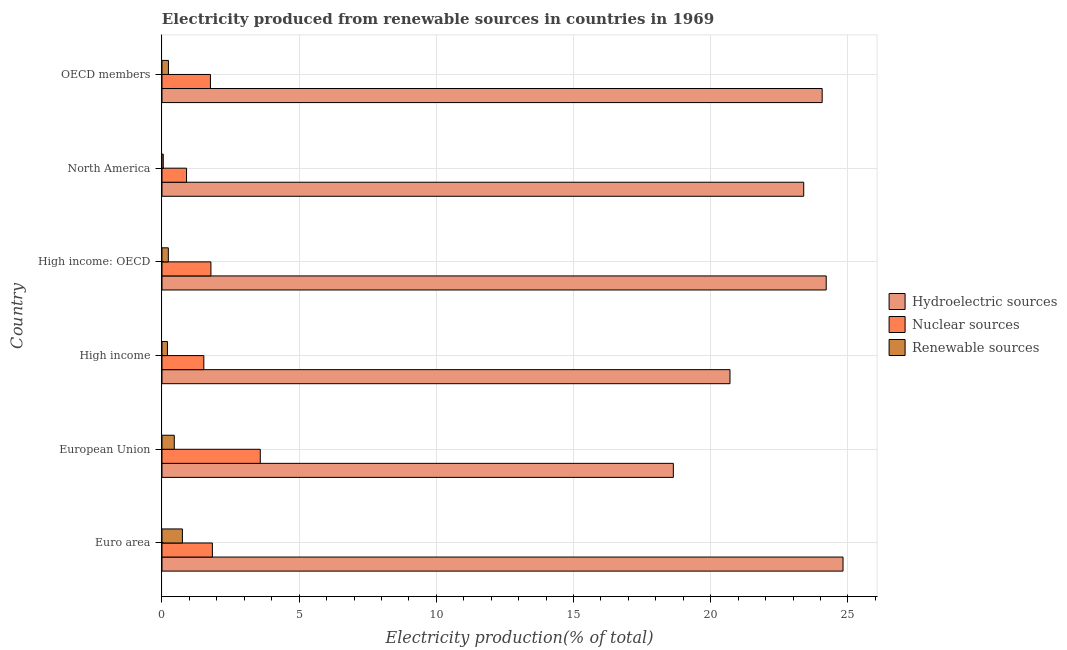How many different coloured bars are there?
Your answer should be very brief. 3. How many groups of bars are there?
Ensure brevity in your answer.  6. What is the label of the 6th group of bars from the top?
Provide a succinct answer. Euro area. What is the percentage of electricity produced by hydroelectric sources in High income: OECD?
Provide a succinct answer. 24.21. Across all countries, what is the maximum percentage of electricity produced by nuclear sources?
Your answer should be compact. 3.58. Across all countries, what is the minimum percentage of electricity produced by nuclear sources?
Make the answer very short. 0.9. What is the total percentage of electricity produced by nuclear sources in the graph?
Provide a succinct answer. 11.39. What is the difference between the percentage of electricity produced by nuclear sources in European Union and that in OECD members?
Provide a short and direct response. 1.82. What is the difference between the percentage of electricity produced by nuclear sources in North America and the percentage of electricity produced by hydroelectric sources in European Union?
Provide a short and direct response. -17.74. What is the average percentage of electricity produced by hydroelectric sources per country?
Give a very brief answer. 22.64. What is the difference between the percentage of electricity produced by hydroelectric sources and percentage of electricity produced by nuclear sources in European Union?
Keep it short and to the point. 15.05. In how many countries, is the percentage of electricity produced by hydroelectric sources greater than 10 %?
Make the answer very short. 6. What is the ratio of the percentage of electricity produced by nuclear sources in Euro area to that in High income: OECD?
Your response must be concise. 1.03. Is the difference between the percentage of electricity produced by nuclear sources in Euro area and High income: OECD greater than the difference between the percentage of electricity produced by hydroelectric sources in Euro area and High income: OECD?
Make the answer very short. No. What is the difference between the highest and the second highest percentage of electricity produced by hydroelectric sources?
Your response must be concise. 0.61. What is the difference between the highest and the lowest percentage of electricity produced by nuclear sources?
Offer a very short reply. 2.69. In how many countries, is the percentage of electricity produced by nuclear sources greater than the average percentage of electricity produced by nuclear sources taken over all countries?
Give a very brief answer. 1. What does the 3rd bar from the top in OECD members represents?
Ensure brevity in your answer.  Hydroelectric sources. What does the 2nd bar from the bottom in Euro area represents?
Give a very brief answer. Nuclear sources. Is it the case that in every country, the sum of the percentage of electricity produced by hydroelectric sources and percentage of electricity produced by nuclear sources is greater than the percentage of electricity produced by renewable sources?
Your response must be concise. Yes. How many bars are there?
Offer a very short reply. 18. Are the values on the major ticks of X-axis written in scientific E-notation?
Give a very brief answer. No. Does the graph contain any zero values?
Your response must be concise. No. Does the graph contain grids?
Offer a terse response. Yes. Where does the legend appear in the graph?
Offer a terse response. Center right. How many legend labels are there?
Keep it short and to the point. 3. What is the title of the graph?
Provide a succinct answer. Electricity produced from renewable sources in countries in 1969. What is the Electricity production(% of total) in Hydroelectric sources in Euro area?
Your response must be concise. 24.82. What is the Electricity production(% of total) in Nuclear sources in Euro area?
Provide a short and direct response. 1.84. What is the Electricity production(% of total) in Renewable sources in Euro area?
Keep it short and to the point. 0.74. What is the Electricity production(% of total) of Hydroelectric sources in European Union?
Make the answer very short. 18.64. What is the Electricity production(% of total) in Nuclear sources in European Union?
Provide a short and direct response. 3.58. What is the Electricity production(% of total) of Renewable sources in European Union?
Your answer should be very brief. 0.45. What is the Electricity production(% of total) in Hydroelectric sources in High income?
Keep it short and to the point. 20.7. What is the Electricity production(% of total) of Nuclear sources in High income?
Your answer should be compact. 1.53. What is the Electricity production(% of total) in Renewable sources in High income?
Give a very brief answer. 0.2. What is the Electricity production(% of total) in Hydroelectric sources in High income: OECD?
Provide a short and direct response. 24.21. What is the Electricity production(% of total) of Nuclear sources in High income: OECD?
Ensure brevity in your answer.  1.78. What is the Electricity production(% of total) in Renewable sources in High income: OECD?
Provide a short and direct response. 0.23. What is the Electricity production(% of total) of Hydroelectric sources in North America?
Keep it short and to the point. 23.39. What is the Electricity production(% of total) of Nuclear sources in North America?
Your response must be concise. 0.9. What is the Electricity production(% of total) in Renewable sources in North America?
Offer a very short reply. 0.05. What is the Electricity production(% of total) of Hydroelectric sources in OECD members?
Provide a succinct answer. 24.06. What is the Electricity production(% of total) of Nuclear sources in OECD members?
Your answer should be very brief. 1.77. What is the Electricity production(% of total) in Renewable sources in OECD members?
Make the answer very short. 0.23. Across all countries, what is the maximum Electricity production(% of total) in Hydroelectric sources?
Your answer should be very brief. 24.82. Across all countries, what is the maximum Electricity production(% of total) of Nuclear sources?
Your answer should be very brief. 3.58. Across all countries, what is the maximum Electricity production(% of total) of Renewable sources?
Provide a succinct answer. 0.74. Across all countries, what is the minimum Electricity production(% of total) of Hydroelectric sources?
Give a very brief answer. 18.64. Across all countries, what is the minimum Electricity production(% of total) of Nuclear sources?
Your answer should be compact. 0.9. Across all countries, what is the minimum Electricity production(% of total) in Renewable sources?
Ensure brevity in your answer.  0.05. What is the total Electricity production(% of total) in Hydroelectric sources in the graph?
Offer a very short reply. 135.82. What is the total Electricity production(% of total) in Nuclear sources in the graph?
Provide a succinct answer. 11.39. What is the total Electricity production(% of total) in Renewable sources in the graph?
Provide a succinct answer. 1.9. What is the difference between the Electricity production(% of total) of Hydroelectric sources in Euro area and that in European Union?
Keep it short and to the point. 6.18. What is the difference between the Electricity production(% of total) of Nuclear sources in Euro area and that in European Union?
Provide a succinct answer. -1.75. What is the difference between the Electricity production(% of total) in Renewable sources in Euro area and that in European Union?
Ensure brevity in your answer.  0.3. What is the difference between the Electricity production(% of total) of Hydroelectric sources in Euro area and that in High income?
Ensure brevity in your answer.  4.12. What is the difference between the Electricity production(% of total) in Nuclear sources in Euro area and that in High income?
Offer a terse response. 0.31. What is the difference between the Electricity production(% of total) of Renewable sources in Euro area and that in High income?
Ensure brevity in your answer.  0.55. What is the difference between the Electricity production(% of total) of Hydroelectric sources in Euro area and that in High income: OECD?
Your answer should be compact. 0.61. What is the difference between the Electricity production(% of total) of Nuclear sources in Euro area and that in High income: OECD?
Give a very brief answer. 0.05. What is the difference between the Electricity production(% of total) of Renewable sources in Euro area and that in High income: OECD?
Your answer should be very brief. 0.51. What is the difference between the Electricity production(% of total) in Hydroelectric sources in Euro area and that in North America?
Offer a very short reply. 1.43. What is the difference between the Electricity production(% of total) in Nuclear sources in Euro area and that in North America?
Your answer should be compact. 0.94. What is the difference between the Electricity production(% of total) in Renewable sources in Euro area and that in North America?
Give a very brief answer. 0.7. What is the difference between the Electricity production(% of total) in Hydroelectric sources in Euro area and that in OECD members?
Offer a terse response. 0.76. What is the difference between the Electricity production(% of total) in Nuclear sources in Euro area and that in OECD members?
Provide a short and direct response. 0.07. What is the difference between the Electricity production(% of total) of Renewable sources in Euro area and that in OECD members?
Your answer should be very brief. 0.51. What is the difference between the Electricity production(% of total) of Hydroelectric sources in European Union and that in High income?
Offer a very short reply. -2.07. What is the difference between the Electricity production(% of total) in Nuclear sources in European Union and that in High income?
Provide a succinct answer. 2.06. What is the difference between the Electricity production(% of total) of Renewable sources in European Union and that in High income?
Provide a succinct answer. 0.25. What is the difference between the Electricity production(% of total) of Hydroelectric sources in European Union and that in High income: OECD?
Make the answer very short. -5.57. What is the difference between the Electricity production(% of total) of Nuclear sources in European Union and that in High income: OECD?
Give a very brief answer. 1.8. What is the difference between the Electricity production(% of total) of Renewable sources in European Union and that in High income: OECD?
Your answer should be compact. 0.22. What is the difference between the Electricity production(% of total) of Hydroelectric sources in European Union and that in North America?
Your response must be concise. -4.75. What is the difference between the Electricity production(% of total) of Nuclear sources in European Union and that in North America?
Ensure brevity in your answer.  2.69. What is the difference between the Electricity production(% of total) in Renewable sources in European Union and that in North America?
Ensure brevity in your answer.  0.4. What is the difference between the Electricity production(% of total) of Hydroelectric sources in European Union and that in OECD members?
Make the answer very short. -5.42. What is the difference between the Electricity production(% of total) in Nuclear sources in European Union and that in OECD members?
Your answer should be compact. 1.82. What is the difference between the Electricity production(% of total) in Renewable sources in European Union and that in OECD members?
Ensure brevity in your answer.  0.21. What is the difference between the Electricity production(% of total) of Hydroelectric sources in High income and that in High income: OECD?
Give a very brief answer. -3.51. What is the difference between the Electricity production(% of total) in Nuclear sources in High income and that in High income: OECD?
Your response must be concise. -0.26. What is the difference between the Electricity production(% of total) of Renewable sources in High income and that in High income: OECD?
Provide a short and direct response. -0.03. What is the difference between the Electricity production(% of total) in Hydroelectric sources in High income and that in North America?
Keep it short and to the point. -2.69. What is the difference between the Electricity production(% of total) in Nuclear sources in High income and that in North America?
Offer a terse response. 0.63. What is the difference between the Electricity production(% of total) in Renewable sources in High income and that in North America?
Offer a terse response. 0.15. What is the difference between the Electricity production(% of total) in Hydroelectric sources in High income and that in OECD members?
Provide a short and direct response. -3.36. What is the difference between the Electricity production(% of total) of Nuclear sources in High income and that in OECD members?
Give a very brief answer. -0.24. What is the difference between the Electricity production(% of total) in Renewable sources in High income and that in OECD members?
Provide a short and direct response. -0.04. What is the difference between the Electricity production(% of total) in Hydroelectric sources in High income: OECD and that in North America?
Offer a terse response. 0.82. What is the difference between the Electricity production(% of total) of Nuclear sources in High income: OECD and that in North America?
Your response must be concise. 0.89. What is the difference between the Electricity production(% of total) in Renewable sources in High income: OECD and that in North America?
Your answer should be compact. 0.18. What is the difference between the Electricity production(% of total) of Hydroelectric sources in High income: OECD and that in OECD members?
Offer a terse response. 0.15. What is the difference between the Electricity production(% of total) in Nuclear sources in High income: OECD and that in OECD members?
Give a very brief answer. 0.02. What is the difference between the Electricity production(% of total) in Renewable sources in High income: OECD and that in OECD members?
Ensure brevity in your answer.  -0. What is the difference between the Electricity production(% of total) in Hydroelectric sources in North America and that in OECD members?
Keep it short and to the point. -0.67. What is the difference between the Electricity production(% of total) of Nuclear sources in North America and that in OECD members?
Provide a short and direct response. -0.87. What is the difference between the Electricity production(% of total) of Renewable sources in North America and that in OECD members?
Provide a succinct answer. -0.19. What is the difference between the Electricity production(% of total) of Hydroelectric sources in Euro area and the Electricity production(% of total) of Nuclear sources in European Union?
Provide a succinct answer. 21.24. What is the difference between the Electricity production(% of total) of Hydroelectric sources in Euro area and the Electricity production(% of total) of Renewable sources in European Union?
Provide a short and direct response. 24.37. What is the difference between the Electricity production(% of total) of Nuclear sources in Euro area and the Electricity production(% of total) of Renewable sources in European Union?
Ensure brevity in your answer.  1.39. What is the difference between the Electricity production(% of total) in Hydroelectric sources in Euro area and the Electricity production(% of total) in Nuclear sources in High income?
Keep it short and to the point. 23.3. What is the difference between the Electricity production(% of total) in Hydroelectric sources in Euro area and the Electricity production(% of total) in Renewable sources in High income?
Give a very brief answer. 24.62. What is the difference between the Electricity production(% of total) in Nuclear sources in Euro area and the Electricity production(% of total) in Renewable sources in High income?
Ensure brevity in your answer.  1.64. What is the difference between the Electricity production(% of total) of Hydroelectric sources in Euro area and the Electricity production(% of total) of Nuclear sources in High income: OECD?
Make the answer very short. 23.04. What is the difference between the Electricity production(% of total) in Hydroelectric sources in Euro area and the Electricity production(% of total) in Renewable sources in High income: OECD?
Your response must be concise. 24.59. What is the difference between the Electricity production(% of total) in Nuclear sources in Euro area and the Electricity production(% of total) in Renewable sources in High income: OECD?
Provide a succinct answer. 1.61. What is the difference between the Electricity production(% of total) in Hydroelectric sources in Euro area and the Electricity production(% of total) in Nuclear sources in North America?
Offer a very short reply. 23.93. What is the difference between the Electricity production(% of total) in Hydroelectric sources in Euro area and the Electricity production(% of total) in Renewable sources in North America?
Your response must be concise. 24.78. What is the difference between the Electricity production(% of total) in Nuclear sources in Euro area and the Electricity production(% of total) in Renewable sources in North America?
Provide a succinct answer. 1.79. What is the difference between the Electricity production(% of total) of Hydroelectric sources in Euro area and the Electricity production(% of total) of Nuclear sources in OECD members?
Give a very brief answer. 23.06. What is the difference between the Electricity production(% of total) in Hydroelectric sources in Euro area and the Electricity production(% of total) in Renewable sources in OECD members?
Offer a very short reply. 24.59. What is the difference between the Electricity production(% of total) of Nuclear sources in Euro area and the Electricity production(% of total) of Renewable sources in OECD members?
Your answer should be compact. 1.6. What is the difference between the Electricity production(% of total) in Hydroelectric sources in European Union and the Electricity production(% of total) in Nuclear sources in High income?
Provide a succinct answer. 17.11. What is the difference between the Electricity production(% of total) of Hydroelectric sources in European Union and the Electricity production(% of total) of Renewable sources in High income?
Your answer should be very brief. 18.44. What is the difference between the Electricity production(% of total) of Nuclear sources in European Union and the Electricity production(% of total) of Renewable sources in High income?
Your answer should be compact. 3.38. What is the difference between the Electricity production(% of total) in Hydroelectric sources in European Union and the Electricity production(% of total) in Nuclear sources in High income: OECD?
Your answer should be very brief. 16.85. What is the difference between the Electricity production(% of total) in Hydroelectric sources in European Union and the Electricity production(% of total) in Renewable sources in High income: OECD?
Offer a very short reply. 18.41. What is the difference between the Electricity production(% of total) of Nuclear sources in European Union and the Electricity production(% of total) of Renewable sources in High income: OECD?
Ensure brevity in your answer.  3.35. What is the difference between the Electricity production(% of total) of Hydroelectric sources in European Union and the Electricity production(% of total) of Nuclear sources in North America?
Make the answer very short. 17.74. What is the difference between the Electricity production(% of total) of Hydroelectric sources in European Union and the Electricity production(% of total) of Renewable sources in North America?
Ensure brevity in your answer.  18.59. What is the difference between the Electricity production(% of total) in Nuclear sources in European Union and the Electricity production(% of total) in Renewable sources in North America?
Make the answer very short. 3.54. What is the difference between the Electricity production(% of total) in Hydroelectric sources in European Union and the Electricity production(% of total) in Nuclear sources in OECD members?
Give a very brief answer. 16.87. What is the difference between the Electricity production(% of total) of Hydroelectric sources in European Union and the Electricity production(% of total) of Renewable sources in OECD members?
Give a very brief answer. 18.4. What is the difference between the Electricity production(% of total) in Nuclear sources in European Union and the Electricity production(% of total) in Renewable sources in OECD members?
Offer a terse response. 3.35. What is the difference between the Electricity production(% of total) of Hydroelectric sources in High income and the Electricity production(% of total) of Nuclear sources in High income: OECD?
Your answer should be compact. 18.92. What is the difference between the Electricity production(% of total) of Hydroelectric sources in High income and the Electricity production(% of total) of Renewable sources in High income: OECD?
Ensure brevity in your answer.  20.47. What is the difference between the Electricity production(% of total) of Nuclear sources in High income and the Electricity production(% of total) of Renewable sources in High income: OECD?
Your response must be concise. 1.29. What is the difference between the Electricity production(% of total) of Hydroelectric sources in High income and the Electricity production(% of total) of Nuclear sources in North America?
Your response must be concise. 19.81. What is the difference between the Electricity production(% of total) of Hydroelectric sources in High income and the Electricity production(% of total) of Renewable sources in North America?
Offer a very short reply. 20.66. What is the difference between the Electricity production(% of total) in Nuclear sources in High income and the Electricity production(% of total) in Renewable sources in North America?
Give a very brief answer. 1.48. What is the difference between the Electricity production(% of total) of Hydroelectric sources in High income and the Electricity production(% of total) of Nuclear sources in OECD members?
Provide a short and direct response. 18.94. What is the difference between the Electricity production(% of total) of Hydroelectric sources in High income and the Electricity production(% of total) of Renewable sources in OECD members?
Your answer should be very brief. 20.47. What is the difference between the Electricity production(% of total) in Nuclear sources in High income and the Electricity production(% of total) in Renewable sources in OECD members?
Keep it short and to the point. 1.29. What is the difference between the Electricity production(% of total) of Hydroelectric sources in High income: OECD and the Electricity production(% of total) of Nuclear sources in North America?
Give a very brief answer. 23.31. What is the difference between the Electricity production(% of total) of Hydroelectric sources in High income: OECD and the Electricity production(% of total) of Renewable sources in North America?
Offer a very short reply. 24.16. What is the difference between the Electricity production(% of total) of Nuclear sources in High income: OECD and the Electricity production(% of total) of Renewable sources in North America?
Give a very brief answer. 1.74. What is the difference between the Electricity production(% of total) of Hydroelectric sources in High income: OECD and the Electricity production(% of total) of Nuclear sources in OECD members?
Offer a very short reply. 22.44. What is the difference between the Electricity production(% of total) of Hydroelectric sources in High income: OECD and the Electricity production(% of total) of Renewable sources in OECD members?
Ensure brevity in your answer.  23.97. What is the difference between the Electricity production(% of total) of Nuclear sources in High income: OECD and the Electricity production(% of total) of Renewable sources in OECD members?
Your answer should be very brief. 1.55. What is the difference between the Electricity production(% of total) in Hydroelectric sources in North America and the Electricity production(% of total) in Nuclear sources in OECD members?
Keep it short and to the point. 21.62. What is the difference between the Electricity production(% of total) in Hydroelectric sources in North America and the Electricity production(% of total) in Renewable sources in OECD members?
Offer a terse response. 23.16. What is the difference between the Electricity production(% of total) of Nuclear sources in North America and the Electricity production(% of total) of Renewable sources in OECD members?
Ensure brevity in your answer.  0.66. What is the average Electricity production(% of total) of Hydroelectric sources per country?
Offer a very short reply. 22.64. What is the average Electricity production(% of total) of Nuclear sources per country?
Offer a very short reply. 1.9. What is the average Electricity production(% of total) of Renewable sources per country?
Offer a very short reply. 0.32. What is the difference between the Electricity production(% of total) of Hydroelectric sources and Electricity production(% of total) of Nuclear sources in Euro area?
Provide a short and direct response. 22.99. What is the difference between the Electricity production(% of total) of Hydroelectric sources and Electricity production(% of total) of Renewable sources in Euro area?
Ensure brevity in your answer.  24.08. What is the difference between the Electricity production(% of total) of Nuclear sources and Electricity production(% of total) of Renewable sources in Euro area?
Provide a short and direct response. 1.09. What is the difference between the Electricity production(% of total) in Hydroelectric sources and Electricity production(% of total) in Nuclear sources in European Union?
Your response must be concise. 15.05. What is the difference between the Electricity production(% of total) of Hydroelectric sources and Electricity production(% of total) of Renewable sources in European Union?
Provide a succinct answer. 18.19. What is the difference between the Electricity production(% of total) in Nuclear sources and Electricity production(% of total) in Renewable sources in European Union?
Offer a very short reply. 3.13. What is the difference between the Electricity production(% of total) in Hydroelectric sources and Electricity production(% of total) in Nuclear sources in High income?
Ensure brevity in your answer.  19.18. What is the difference between the Electricity production(% of total) of Hydroelectric sources and Electricity production(% of total) of Renewable sources in High income?
Offer a very short reply. 20.5. What is the difference between the Electricity production(% of total) of Nuclear sources and Electricity production(% of total) of Renewable sources in High income?
Your response must be concise. 1.33. What is the difference between the Electricity production(% of total) of Hydroelectric sources and Electricity production(% of total) of Nuclear sources in High income: OECD?
Give a very brief answer. 22.43. What is the difference between the Electricity production(% of total) of Hydroelectric sources and Electricity production(% of total) of Renewable sources in High income: OECD?
Provide a short and direct response. 23.98. What is the difference between the Electricity production(% of total) of Nuclear sources and Electricity production(% of total) of Renewable sources in High income: OECD?
Offer a very short reply. 1.55. What is the difference between the Electricity production(% of total) in Hydroelectric sources and Electricity production(% of total) in Nuclear sources in North America?
Your response must be concise. 22.49. What is the difference between the Electricity production(% of total) in Hydroelectric sources and Electricity production(% of total) in Renewable sources in North America?
Your answer should be very brief. 23.34. What is the difference between the Electricity production(% of total) in Nuclear sources and Electricity production(% of total) in Renewable sources in North America?
Your answer should be very brief. 0.85. What is the difference between the Electricity production(% of total) of Hydroelectric sources and Electricity production(% of total) of Nuclear sources in OECD members?
Offer a very short reply. 22.3. What is the difference between the Electricity production(% of total) in Hydroelectric sources and Electricity production(% of total) in Renewable sources in OECD members?
Your answer should be compact. 23.83. What is the difference between the Electricity production(% of total) of Nuclear sources and Electricity production(% of total) of Renewable sources in OECD members?
Your answer should be very brief. 1.53. What is the ratio of the Electricity production(% of total) of Hydroelectric sources in Euro area to that in European Union?
Your response must be concise. 1.33. What is the ratio of the Electricity production(% of total) in Nuclear sources in Euro area to that in European Union?
Provide a succinct answer. 0.51. What is the ratio of the Electricity production(% of total) in Renewable sources in Euro area to that in European Union?
Provide a succinct answer. 1.66. What is the ratio of the Electricity production(% of total) in Hydroelectric sources in Euro area to that in High income?
Provide a short and direct response. 1.2. What is the ratio of the Electricity production(% of total) in Nuclear sources in Euro area to that in High income?
Your answer should be compact. 1.2. What is the ratio of the Electricity production(% of total) in Renewable sources in Euro area to that in High income?
Your answer should be compact. 3.76. What is the ratio of the Electricity production(% of total) of Hydroelectric sources in Euro area to that in High income: OECD?
Make the answer very short. 1.03. What is the ratio of the Electricity production(% of total) of Nuclear sources in Euro area to that in High income: OECD?
Ensure brevity in your answer.  1.03. What is the ratio of the Electricity production(% of total) in Renewable sources in Euro area to that in High income: OECD?
Your answer should be compact. 3.22. What is the ratio of the Electricity production(% of total) in Hydroelectric sources in Euro area to that in North America?
Your answer should be compact. 1.06. What is the ratio of the Electricity production(% of total) of Nuclear sources in Euro area to that in North America?
Offer a terse response. 2.05. What is the ratio of the Electricity production(% of total) in Renewable sources in Euro area to that in North America?
Give a very brief answer. 16.05. What is the ratio of the Electricity production(% of total) of Hydroelectric sources in Euro area to that in OECD members?
Make the answer very short. 1.03. What is the ratio of the Electricity production(% of total) of Nuclear sources in Euro area to that in OECD members?
Give a very brief answer. 1.04. What is the ratio of the Electricity production(% of total) of Renewable sources in Euro area to that in OECD members?
Ensure brevity in your answer.  3.18. What is the ratio of the Electricity production(% of total) of Hydroelectric sources in European Union to that in High income?
Keep it short and to the point. 0.9. What is the ratio of the Electricity production(% of total) in Nuclear sources in European Union to that in High income?
Your response must be concise. 2.35. What is the ratio of the Electricity production(% of total) of Renewable sources in European Union to that in High income?
Your response must be concise. 2.26. What is the ratio of the Electricity production(% of total) in Hydroelectric sources in European Union to that in High income: OECD?
Ensure brevity in your answer.  0.77. What is the ratio of the Electricity production(% of total) of Nuclear sources in European Union to that in High income: OECD?
Provide a succinct answer. 2.01. What is the ratio of the Electricity production(% of total) in Renewable sources in European Union to that in High income: OECD?
Provide a succinct answer. 1.94. What is the ratio of the Electricity production(% of total) of Hydroelectric sources in European Union to that in North America?
Offer a terse response. 0.8. What is the ratio of the Electricity production(% of total) in Nuclear sources in European Union to that in North America?
Give a very brief answer. 4. What is the ratio of the Electricity production(% of total) of Renewable sources in European Union to that in North America?
Your answer should be very brief. 9.67. What is the ratio of the Electricity production(% of total) in Hydroelectric sources in European Union to that in OECD members?
Your answer should be compact. 0.77. What is the ratio of the Electricity production(% of total) in Nuclear sources in European Union to that in OECD members?
Make the answer very short. 2.03. What is the ratio of the Electricity production(% of total) of Renewable sources in European Union to that in OECD members?
Provide a succinct answer. 1.91. What is the ratio of the Electricity production(% of total) of Hydroelectric sources in High income to that in High income: OECD?
Offer a terse response. 0.86. What is the ratio of the Electricity production(% of total) in Nuclear sources in High income to that in High income: OECD?
Provide a short and direct response. 0.86. What is the ratio of the Electricity production(% of total) of Renewable sources in High income to that in High income: OECD?
Offer a terse response. 0.86. What is the ratio of the Electricity production(% of total) of Hydroelectric sources in High income to that in North America?
Your answer should be very brief. 0.89. What is the ratio of the Electricity production(% of total) in Nuclear sources in High income to that in North America?
Make the answer very short. 1.7. What is the ratio of the Electricity production(% of total) in Renewable sources in High income to that in North America?
Your response must be concise. 4.27. What is the ratio of the Electricity production(% of total) of Hydroelectric sources in High income to that in OECD members?
Ensure brevity in your answer.  0.86. What is the ratio of the Electricity production(% of total) in Nuclear sources in High income to that in OECD members?
Keep it short and to the point. 0.86. What is the ratio of the Electricity production(% of total) in Renewable sources in High income to that in OECD members?
Provide a short and direct response. 0.84. What is the ratio of the Electricity production(% of total) of Hydroelectric sources in High income: OECD to that in North America?
Ensure brevity in your answer.  1.04. What is the ratio of the Electricity production(% of total) in Nuclear sources in High income: OECD to that in North America?
Give a very brief answer. 1.99. What is the ratio of the Electricity production(% of total) in Renewable sources in High income: OECD to that in North America?
Your answer should be compact. 4.99. What is the ratio of the Electricity production(% of total) of Nuclear sources in High income: OECD to that in OECD members?
Your answer should be compact. 1.01. What is the ratio of the Electricity production(% of total) of Renewable sources in High income: OECD to that in OECD members?
Your answer should be very brief. 0.99. What is the ratio of the Electricity production(% of total) in Hydroelectric sources in North America to that in OECD members?
Make the answer very short. 0.97. What is the ratio of the Electricity production(% of total) in Nuclear sources in North America to that in OECD members?
Give a very brief answer. 0.51. What is the ratio of the Electricity production(% of total) in Renewable sources in North America to that in OECD members?
Make the answer very short. 0.2. What is the difference between the highest and the second highest Electricity production(% of total) of Hydroelectric sources?
Make the answer very short. 0.61. What is the difference between the highest and the second highest Electricity production(% of total) in Nuclear sources?
Provide a succinct answer. 1.75. What is the difference between the highest and the second highest Electricity production(% of total) in Renewable sources?
Provide a succinct answer. 0.3. What is the difference between the highest and the lowest Electricity production(% of total) in Hydroelectric sources?
Give a very brief answer. 6.18. What is the difference between the highest and the lowest Electricity production(% of total) of Nuclear sources?
Ensure brevity in your answer.  2.69. What is the difference between the highest and the lowest Electricity production(% of total) in Renewable sources?
Offer a terse response. 0.7. 